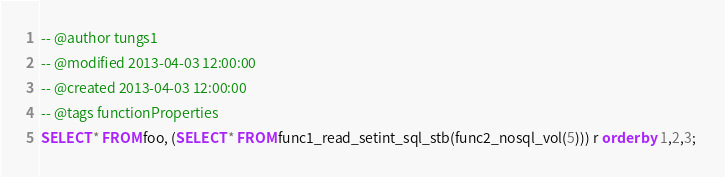<code> <loc_0><loc_0><loc_500><loc_500><_SQL_>
-- @author tungs1
-- @modified 2013-04-03 12:00:00
-- @created 2013-04-03 12:00:00
-- @tags functionProperties 
SELECT * FROM foo, (SELECT * FROM func1_read_setint_sql_stb(func2_nosql_vol(5))) r order by 1,2,3; 
</code> 